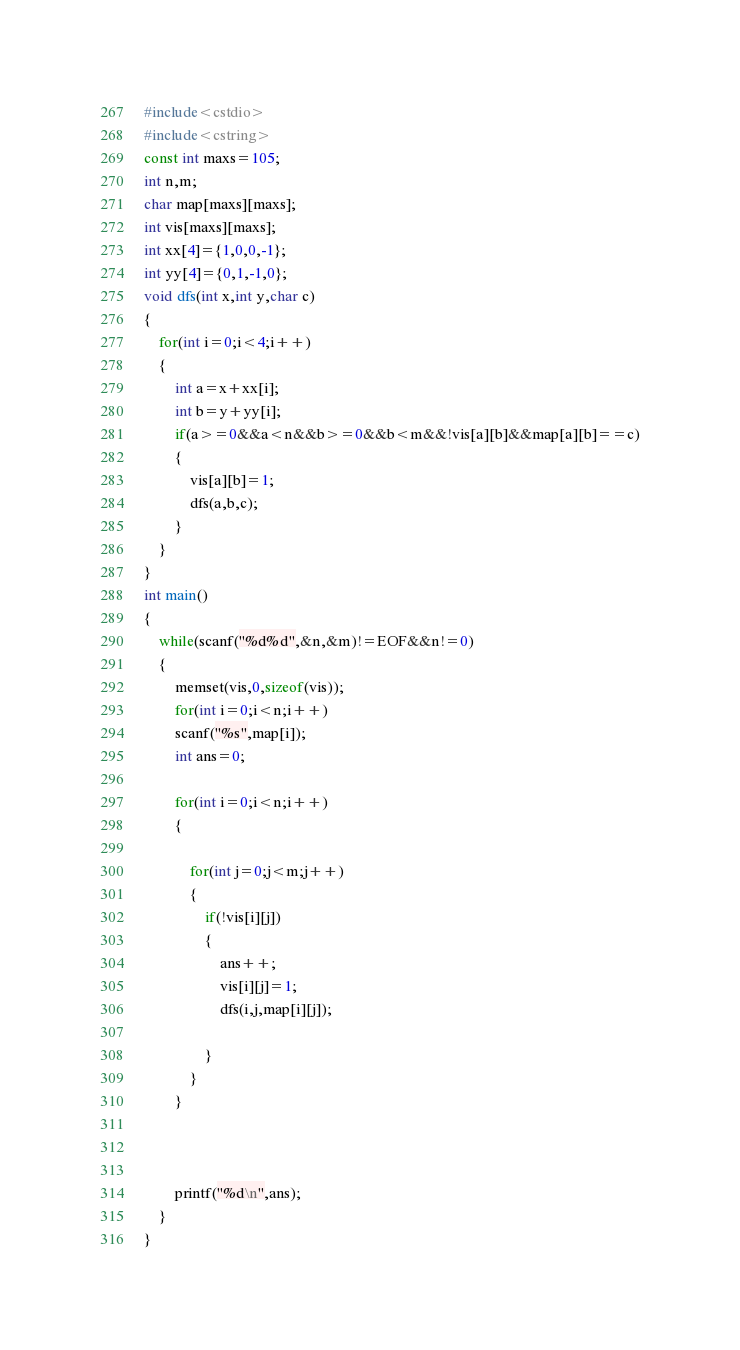Convert code to text. <code><loc_0><loc_0><loc_500><loc_500><_C++_>#include<cstdio>
#include<cstring>
const int maxs=105;
int n,m;
char map[maxs][maxs];
int vis[maxs][maxs];
int xx[4]={1,0,0,-1};
int yy[4]={0,1,-1,0};
void dfs(int x,int y,char c)
{
    for(int i=0;i<4;i++)
    {
        int a=x+xx[i];
        int b=y+yy[i];
        if(a>=0&&a<n&&b>=0&&b<m&&!vis[a][b]&&map[a][b]==c)
        {
            vis[a][b]=1;
            dfs(a,b,c);
        }
    }
}
int main()
{
    while(scanf("%d%d",&n,&m)!=EOF&&n!=0)
    {
        memset(vis,0,sizeof(vis));
        for(int i=0;i<n;i++)
        scanf("%s",map[i]);
        int ans=0;

        for(int i=0;i<n;i++)
        {

            for(int j=0;j<m;j++)
            {
                if(!vis[i][j])
                {
                    ans++;
                    vis[i][j]=1;
                    dfs(i,j,map[i][j]);

                }
            }
        }



        printf("%d\n",ans);
    }
}</code> 